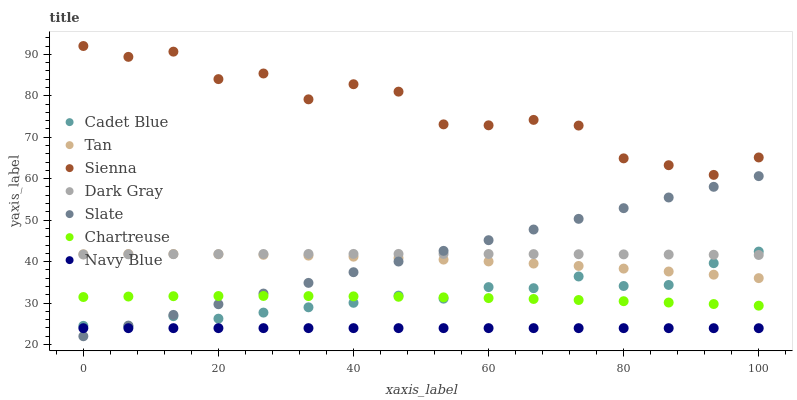Does Navy Blue have the minimum area under the curve?
Answer yes or no. Yes. Does Sienna have the maximum area under the curve?
Answer yes or no. Yes. Does Cadet Blue have the minimum area under the curve?
Answer yes or no. No. Does Cadet Blue have the maximum area under the curve?
Answer yes or no. No. Is Slate the smoothest?
Answer yes or no. Yes. Is Sienna the roughest?
Answer yes or no. Yes. Is Cadet Blue the smoothest?
Answer yes or no. No. Is Cadet Blue the roughest?
Answer yes or no. No. Does Slate have the lowest value?
Answer yes or no. Yes. Does Cadet Blue have the lowest value?
Answer yes or no. No. Does Sienna have the highest value?
Answer yes or no. Yes. Does Cadet Blue have the highest value?
Answer yes or no. No. Is Chartreuse less than Dark Gray?
Answer yes or no. Yes. Is Sienna greater than Tan?
Answer yes or no. Yes. Does Slate intersect Dark Gray?
Answer yes or no. Yes. Is Slate less than Dark Gray?
Answer yes or no. No. Is Slate greater than Dark Gray?
Answer yes or no. No. Does Chartreuse intersect Dark Gray?
Answer yes or no. No. 